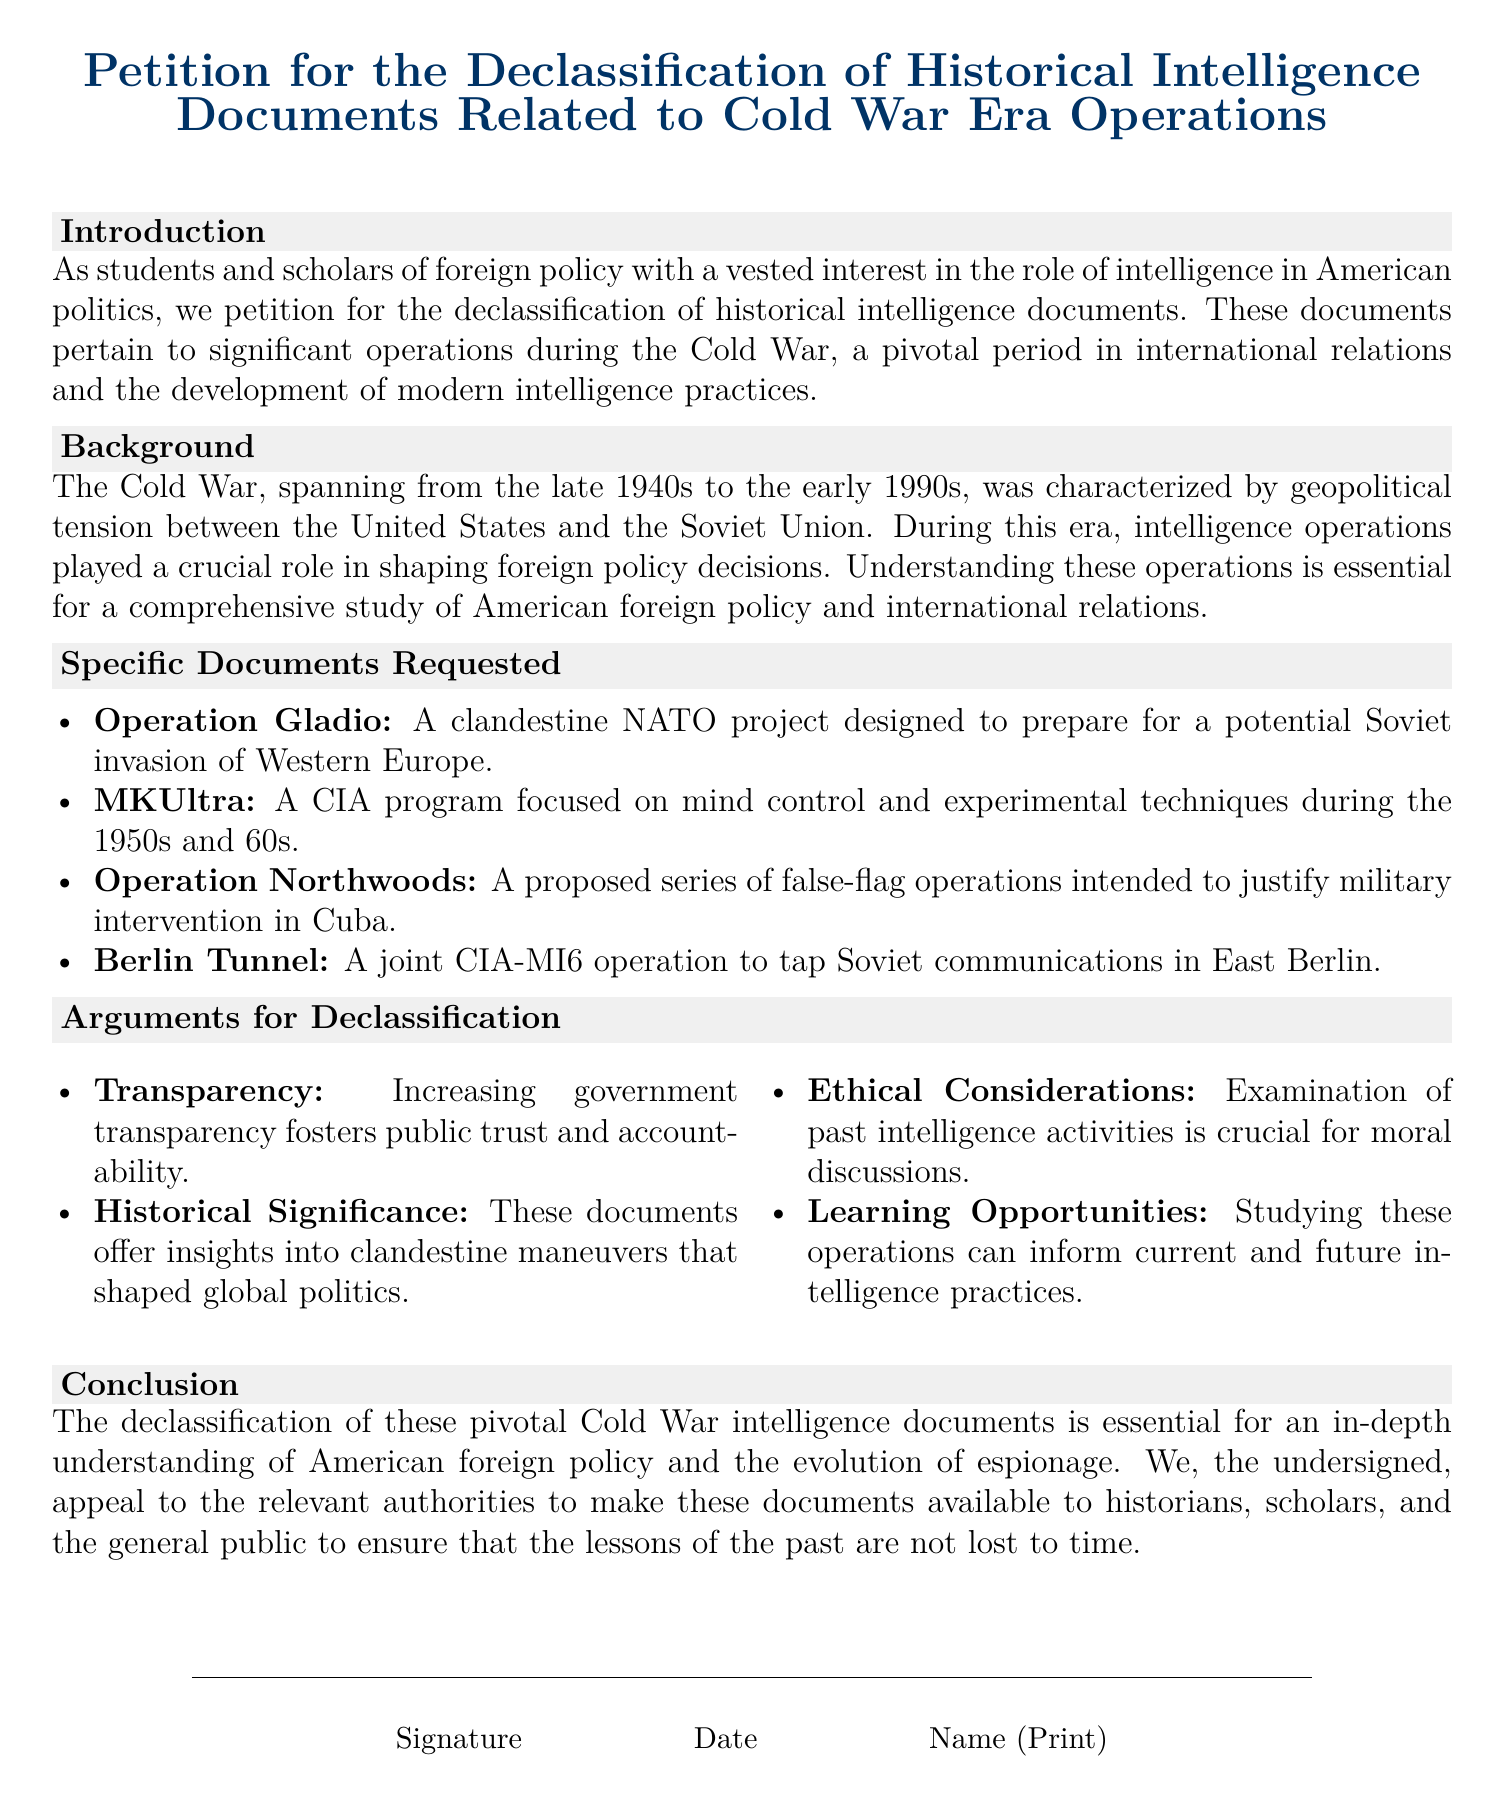What is the title of the petition? The title is prominently displayed at the top of the document, summarizing the focus of the petition.
Answer: Petition for the Declassification of Historical Intelligence Documents Related to Cold War Era Operations How many specific documents are requested for declassification? The document enumerates the specific documents requested in a list format, which indicates the total count.
Answer: Four What operation is related to preparing for a potential Soviet invasion? The document mentions a specific operation that is designed for this scenario, indicating its primary focus.
Answer: Operation Gladio Which organization is associated with the MKUltra program? The document specifies a governmental agency linked to this controversial program.
Answer: CIA What is one argument for declassification mentioned in the document? The document lists multiple reasons for the request, highlighting key points in its arguments.
Answer: Transparency Which two agencies were involved in the Berlin Tunnel operation? The document identifies the specific agencies that collaborated on this intelligence operation.
Answer: CIA and MI6 What is the primary goal of the petition? The document outlines the main purpose behind the petition in the conclusion section.
Answer: Declassification What decades are mentioned in relation to the MKUltra program? The document specifically refers to the time period during which this program was actively in operation.
Answer: 1950s and 60s 